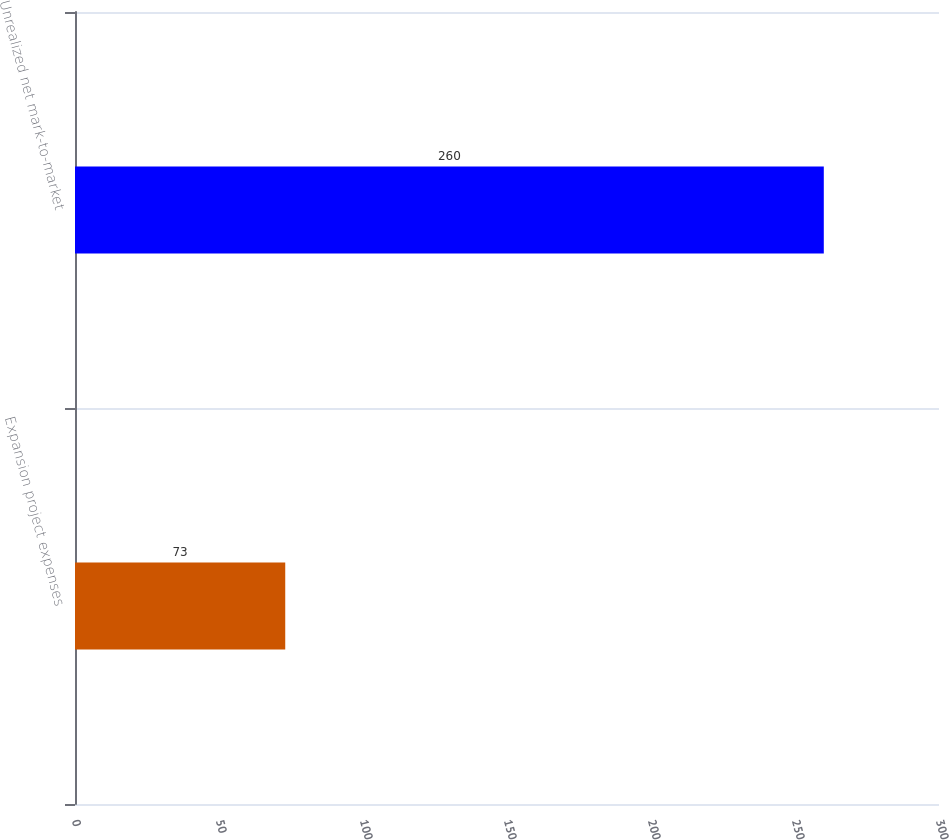<chart> <loc_0><loc_0><loc_500><loc_500><bar_chart><fcel>Expansion project expenses<fcel>Unrealized net mark-to-market<nl><fcel>73<fcel>260<nl></chart> 